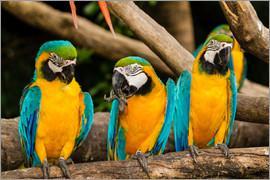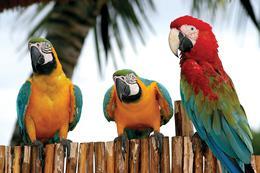The first image is the image on the left, the second image is the image on the right. Assess this claim about the two images: "Each image shows a row of three birds perched on a branch, and no row of birds all share the same coloring.". Correct or not? Answer yes or no. No. 